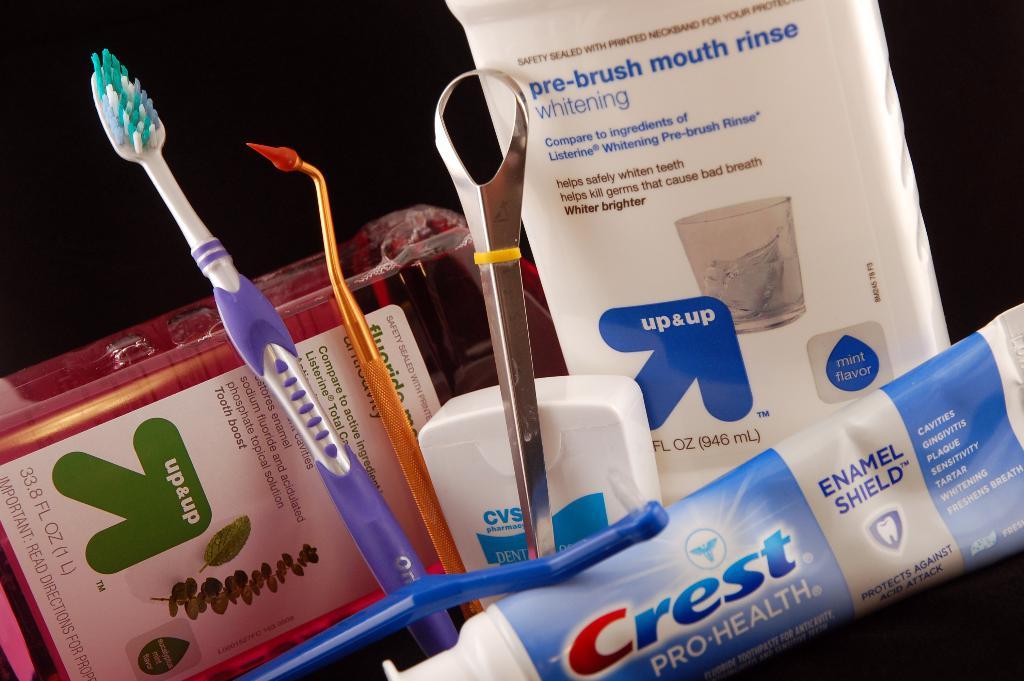What is in the white package?
Make the answer very short. Mouth rinse. What is the brand of toothpaste in front?
Your answer should be compact. Crest. 